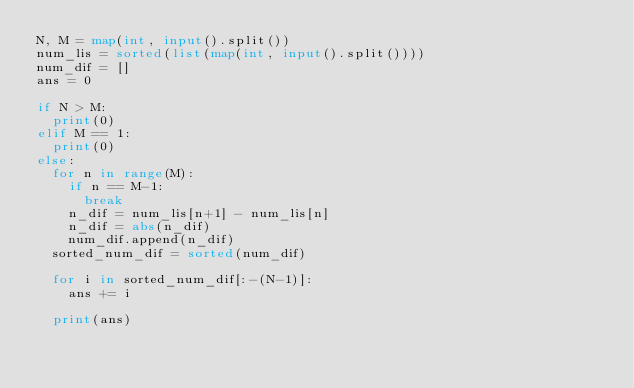Convert code to text. <code><loc_0><loc_0><loc_500><loc_500><_Python_>N, M = map(int, input().split())
num_lis = sorted(list(map(int, input().split())))
num_dif = []
ans = 0

if N > M:
  print(0)
elif M == 1:
  print(0)
else:
  for n in range(M):
    if n == M-1:
      break
    n_dif = num_lis[n+1] - num_lis[n]
    n_dif = abs(n_dif)
    num_dif.append(n_dif)
  sorted_num_dif = sorted(num_dif)
  
  for i in sorted_num_dif[:-(N-1)]:
    ans += i

  print(ans)
</code> 